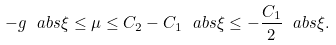<formula> <loc_0><loc_0><loc_500><loc_500>- g \ a b s { \xi } \leq \mu \leq C _ { 2 } - C _ { 1 } \ a b s { \xi } \leq - \frac { C _ { 1 } } { 2 } \ a b s { \xi } .</formula> 